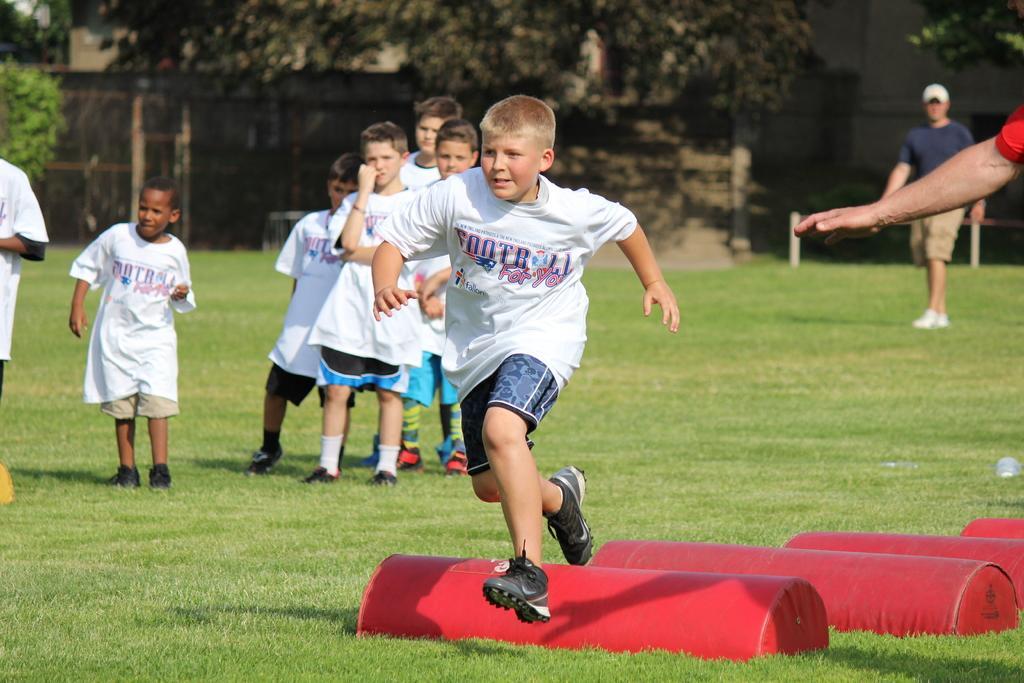How would you summarize this image in a sentence or two? The image is taken in a playground. In the foreground of the picture there are people, hurdles. In the background there are trees, grass and a person. At the bottom it is grass. 